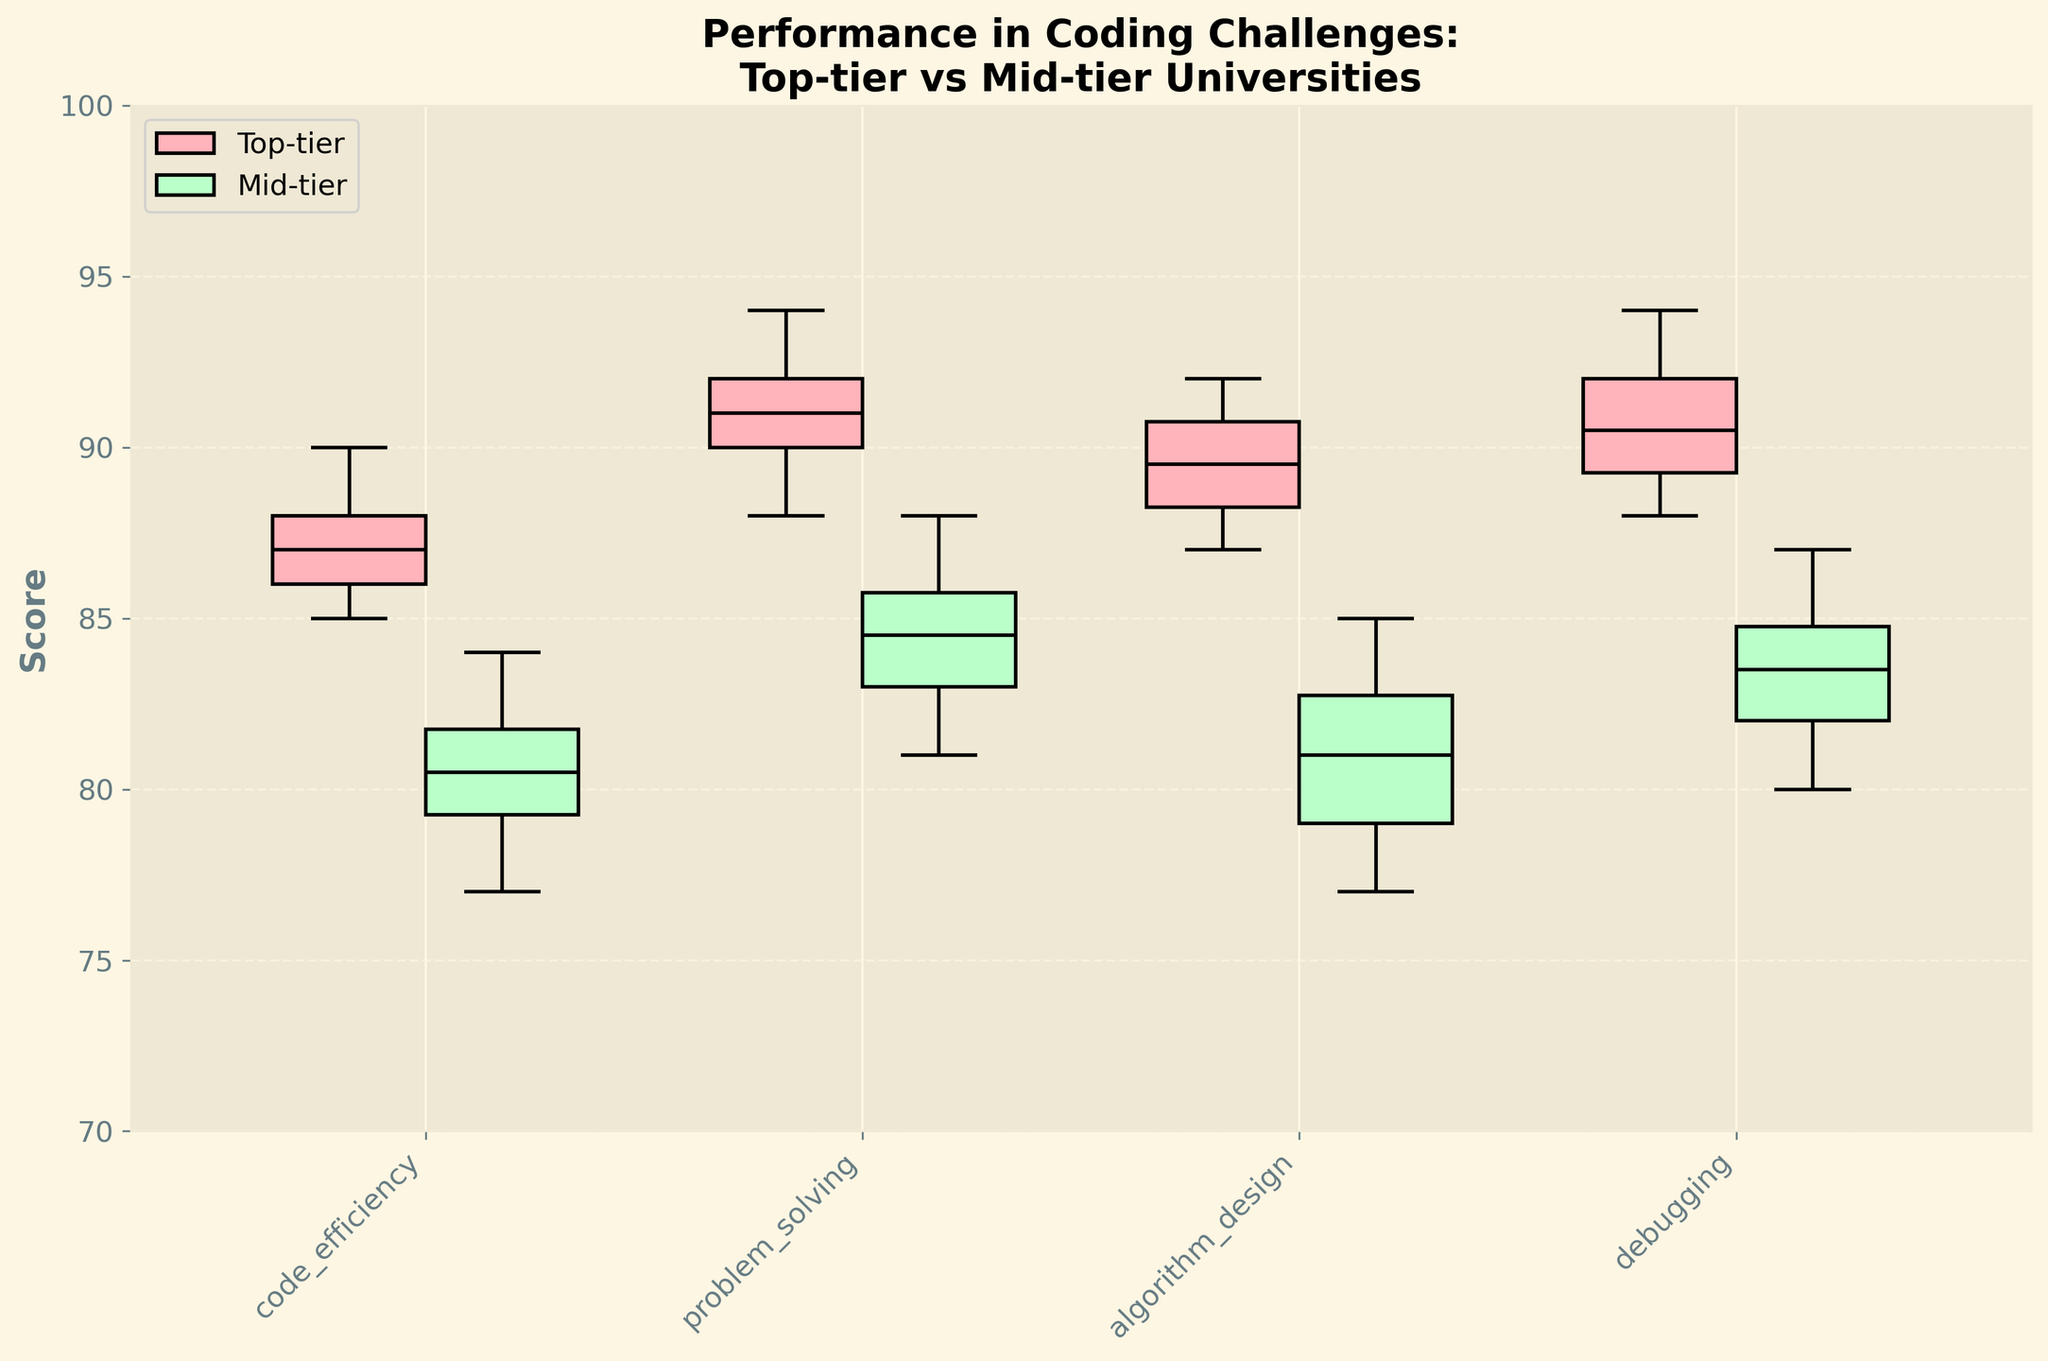What is the title of the plot? The title is displayed at the top of the figure and summarizes the content of the plot. The title reads "Performance in Coding Challenges: Top-tier vs Mid-tier Universities".
Answer: "Performance in Coding Challenges: Top-tier vs Mid-tier Universities" Which categories are displayed on the x-axis? The x-axis lists the categories for which performance is measured in the coding challenges. The categories named are 'code_efficiency,' 'problem_solving,' 'algorithm_design,' and 'debugging'.
Answer: 'code_efficiency,' 'problem_solving,' 'algorithm_design,' and 'debugging' Which group shows higher median scores across all categories? Each boxplot has a line inside it representing the median score for that group. The top-tier group is represented by pink boxplots, and the mid-tier group is represented by green boxplots. Across all categories ('code_efficiency,' 'problem_solving,' 'algorithm_design,' 'debugging'), the pink (top-tier) boxes have higher medians.
Answer: Top-tier group What are the median scores for the top-tier and mid-tier groups in the 'problem_solving' category? The median score is the center line within the box of a box plot. For 'problem_solving,' look at the position of the median lines within the boxes: for top-tier (left pink box), and mid-tier (right green box). The median scores are 91 for top-tier and 85 for mid-tier.
Answer: 91 for top-tier and 85 for mid-tier In which category is the performance difference between top-tier and mid-tier students the greatest? To determine this, compare the positions of the median lines for each pair of categories and see where the score difference between the pink and green boxes is the largest. The largest difference in median scores is in the 'problem_solving' category.
Answer: 'problem_solving' category Which category shows the least variability in scores for top-tier universities? Variability in scores is represented by the width of the box and the overall range encompassed by the whiskers. Compare the widths and whisker lengths of the pink boxes. The 'algorithm_design' category has the smallest box and shortest whiskers, indicating the least variability.
Answer: 'algorithm_design' category Are there any categories where the mid-tier group's median score is higher than the top-tier group's? Examine the position of the median lines for both top-tier and mid-tier groups in each category. There are no categories where the green (mid-tier) median line is above the pink (top-tier) median line.
Answer: No How are the interquartile ranges (IQRs) compared between 'debugging' category scores for both groups? The IQR is the range between the first quartile (bottom of the box) and the third quartile (top of the box). Compare the IQRs of the pink box (top-tier) and green box (mid-tier) in the 'debugging' category. The pink box has a slightly taller box, indicating a larger IQR.
Answer: Larger for top-tier What is the range of scores for top-tier universities in 'algorithm_design'? The range of scores includes the minimum and maximum values represented by the ends of the whiskers. For 'algorithm_design,' the pink box extends from around 88 to 92.
Answer: 88 to 92 